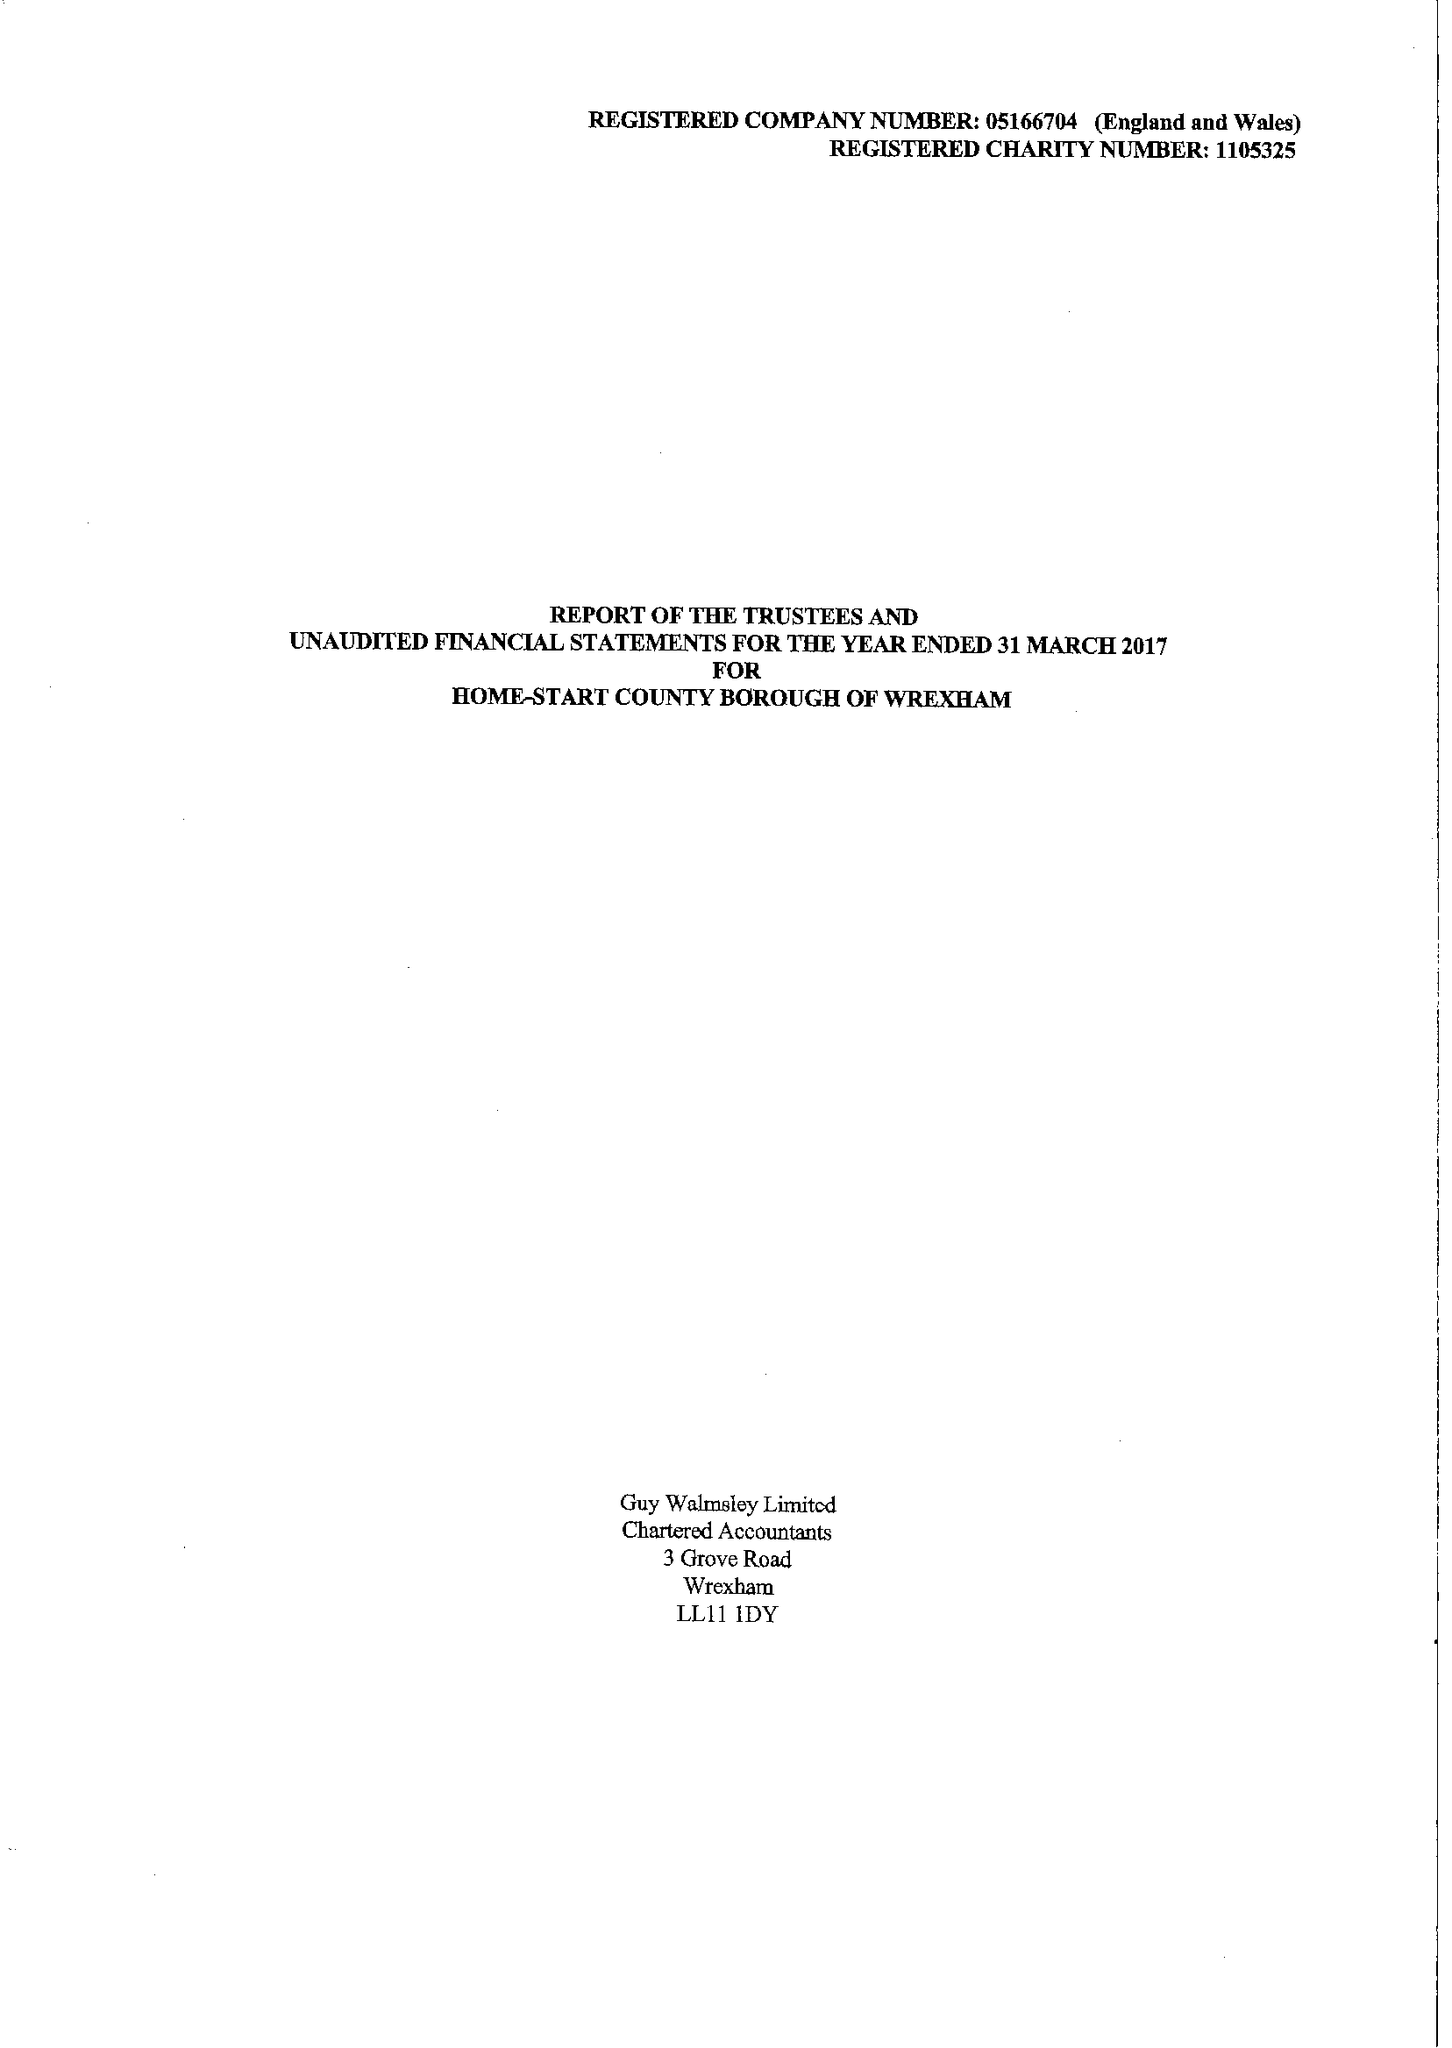What is the value for the address__street_line?
Answer the question using a single word or phrase. GARDEN ROAD 